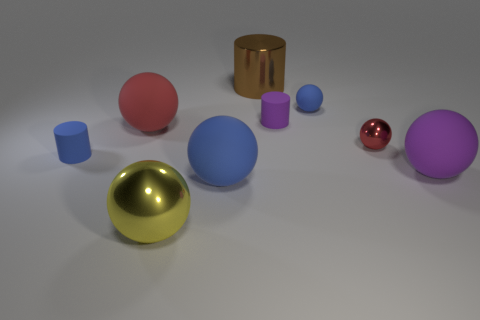Can you describe the arrangement and colors of the objects in the image? In the image, objects of various shapes, colors, and materials are scattered. There are spheres in pink, blue, and red; a gold and a silver sphere give off a metallic sheen. A copper-colored cylinder stands out with its unique shape, alongside a blue cylinder and a purple cube. 